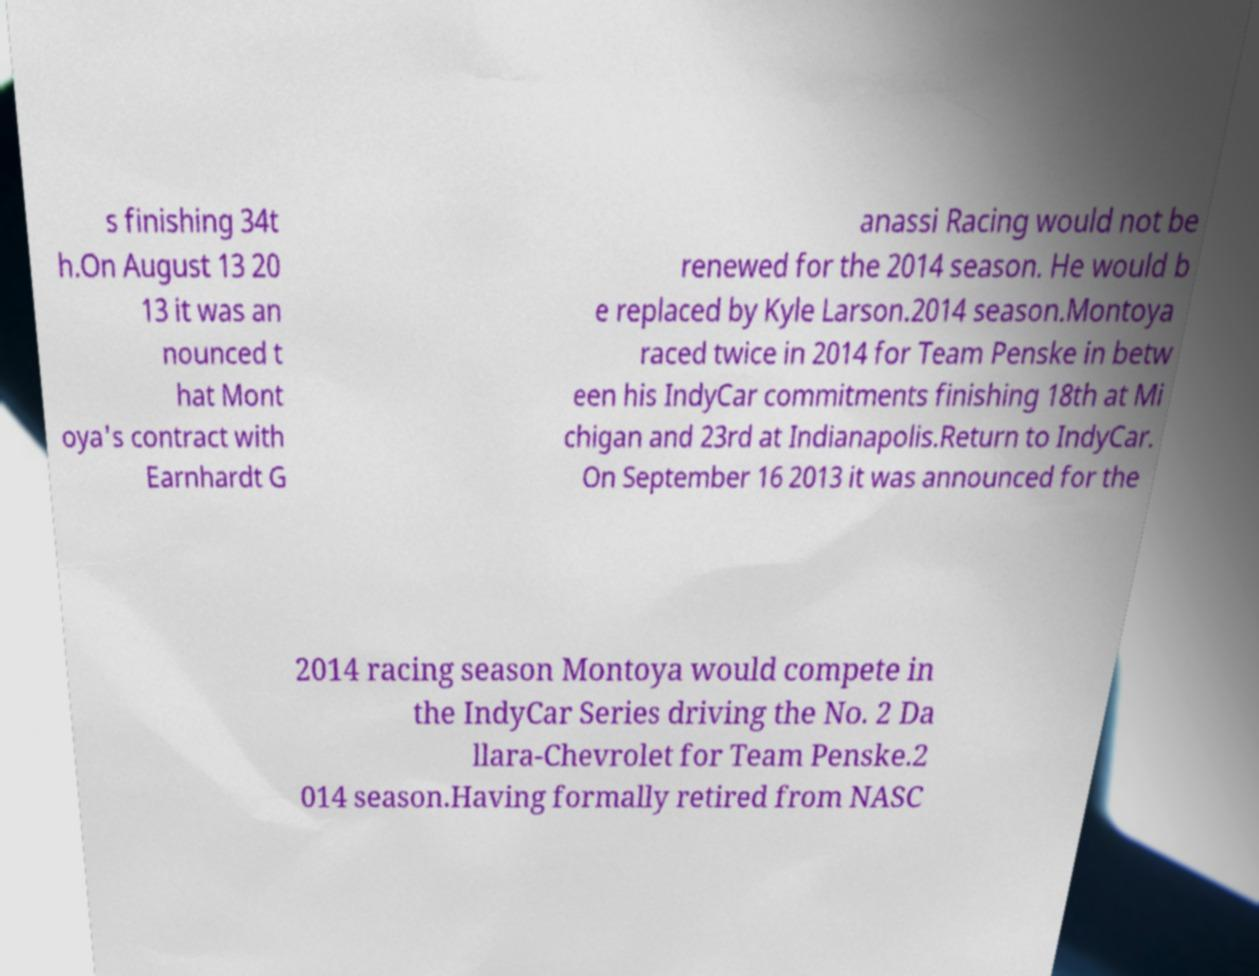Can you accurately transcribe the text from the provided image for me? s finishing 34t h.On August 13 20 13 it was an nounced t hat Mont oya's contract with Earnhardt G anassi Racing would not be renewed for the 2014 season. He would b e replaced by Kyle Larson.2014 season.Montoya raced twice in 2014 for Team Penske in betw een his IndyCar commitments finishing 18th at Mi chigan and 23rd at Indianapolis.Return to IndyCar. On September 16 2013 it was announced for the 2014 racing season Montoya would compete in the IndyCar Series driving the No. 2 Da llara-Chevrolet for Team Penske.2 014 season.Having formally retired from NASC 